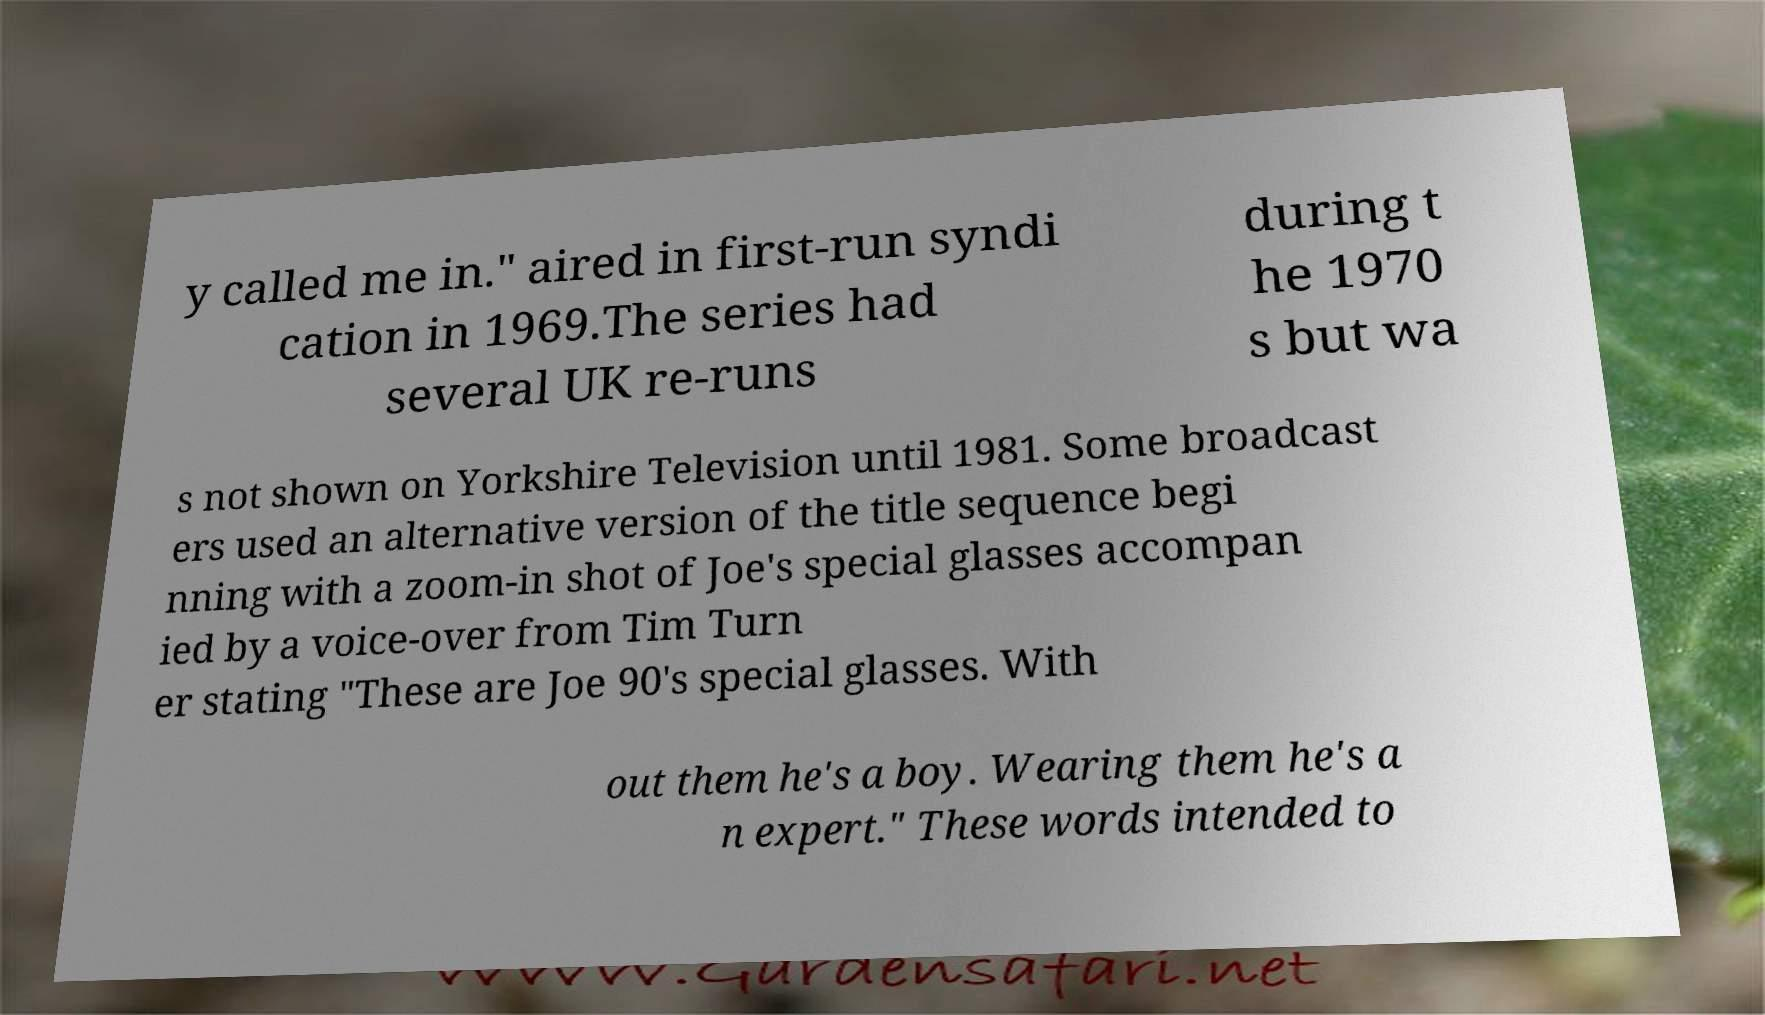Could you assist in decoding the text presented in this image and type it out clearly? y called me in." aired in first-run syndi cation in 1969.The series had several UK re-runs during t he 1970 s but wa s not shown on Yorkshire Television until 1981. Some broadcast ers used an alternative version of the title sequence begi nning with a zoom-in shot of Joe's special glasses accompan ied by a voice-over from Tim Turn er stating "These are Joe 90's special glasses. With out them he's a boy. Wearing them he's a n expert." These words intended to 